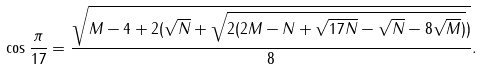<formula> <loc_0><loc_0><loc_500><loc_500>\cos { \frac { \pi } { 1 7 } } = { \frac { \sqrt { M - 4 + 2 ( { \sqrt { N } } + { \sqrt { 2 ( 2 M - N + { \sqrt { 1 7 N } } - { \sqrt { N } } - 8 { \sqrt { M } } ) } } ) } } { 8 } } .</formula> 